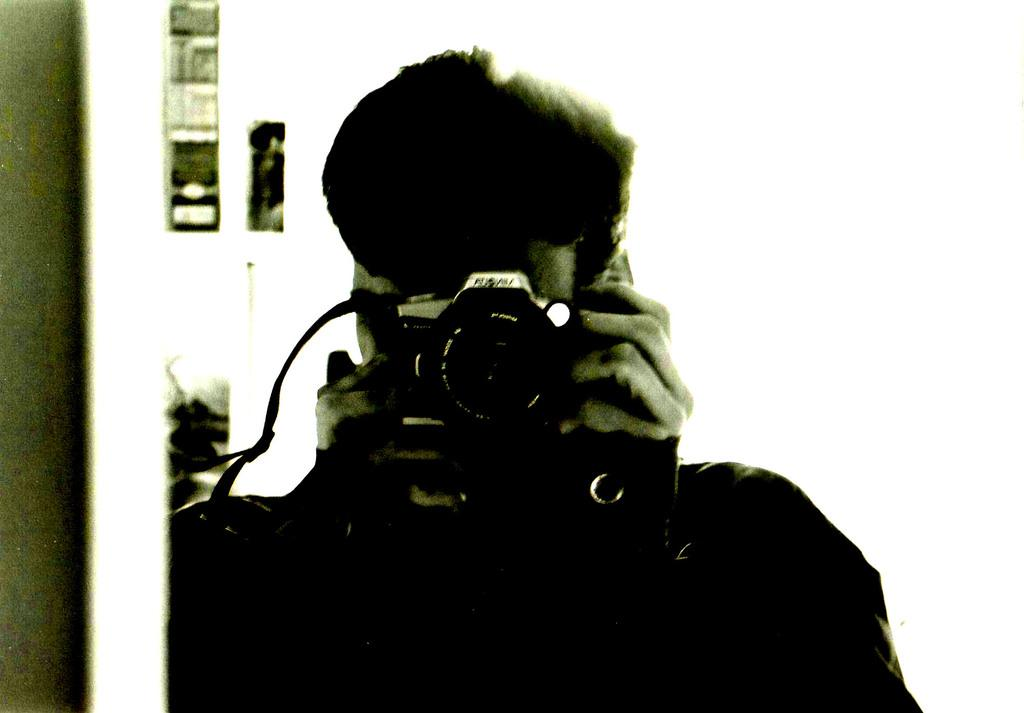What is the color scheme of the image? The image is black and white. Can you describe the person in the image? There is a person in the image. What is the person holding in his hands? The person is holding a camera in his hands. How many beans are visible in the image? There are no beans present in the image. What type of nail is being used by the person in the image? There is no nail being used by the person in the image; they are holding a camera. 